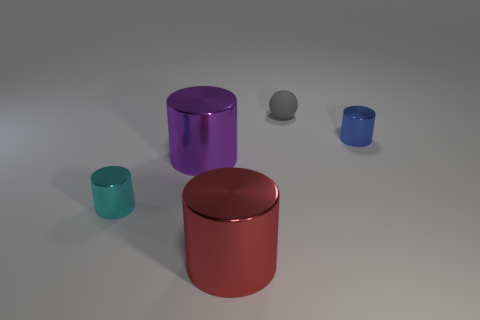Subtract all cyan cylinders. Subtract all yellow spheres. How many cylinders are left? 3 Add 1 tiny matte cubes. How many objects exist? 6 Subtract all cylinders. How many objects are left? 1 Add 1 purple metallic things. How many purple metallic things are left? 2 Add 5 tiny spheres. How many tiny spheres exist? 6 Subtract 0 purple cubes. How many objects are left? 5 Subtract all small cyan spheres. Subtract all big objects. How many objects are left? 3 